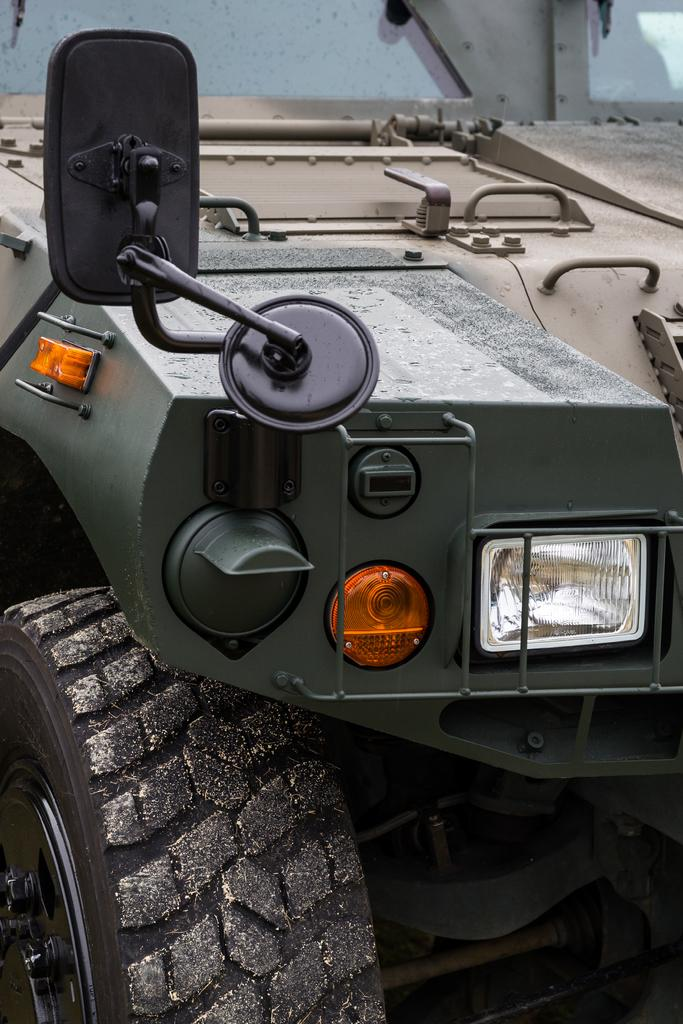What type of vehicle is in the image? There is a jeep in the image. What color is the jeep? The jeep is green in color. How many cattle are grazing on the grass near the jeep in the image? There is no mention of cattle or grass in the image; it only features a green jeep. 